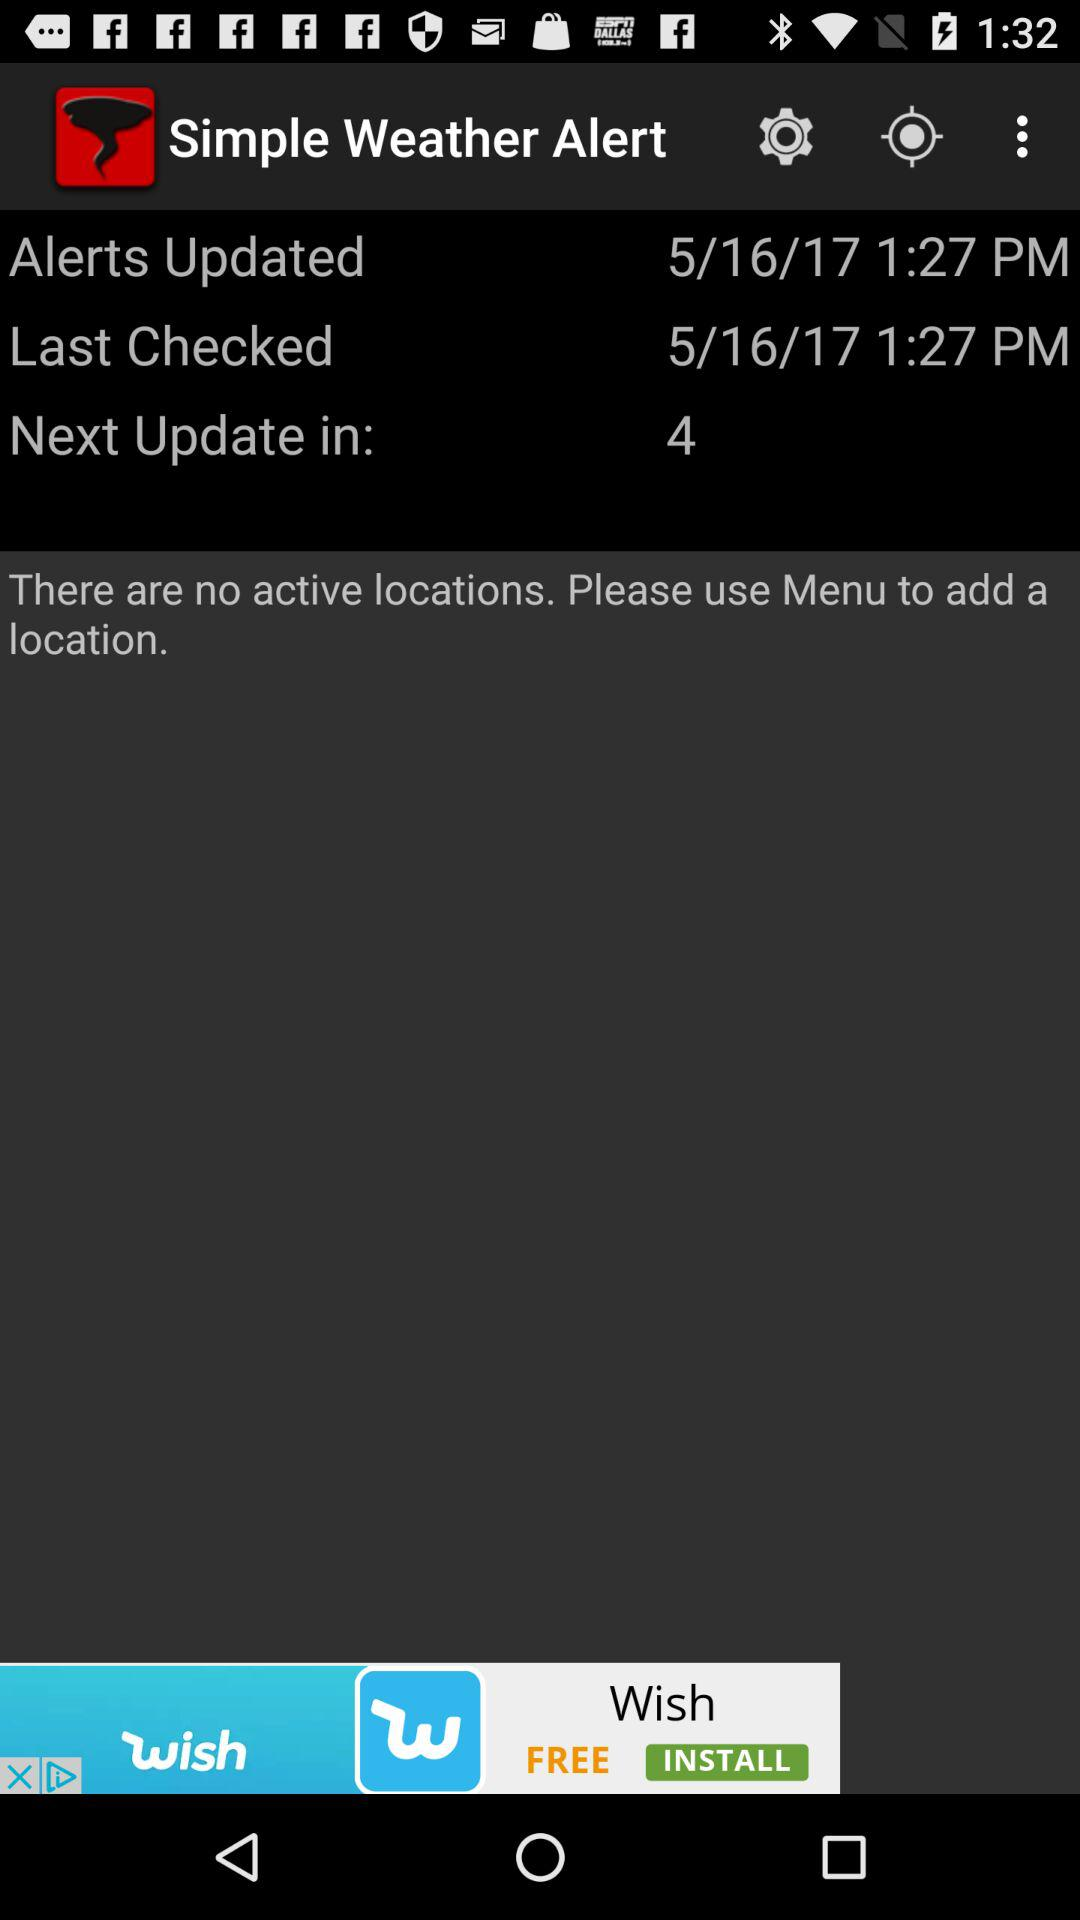When was the alert last updated? It was updated on May 16, 2017. 